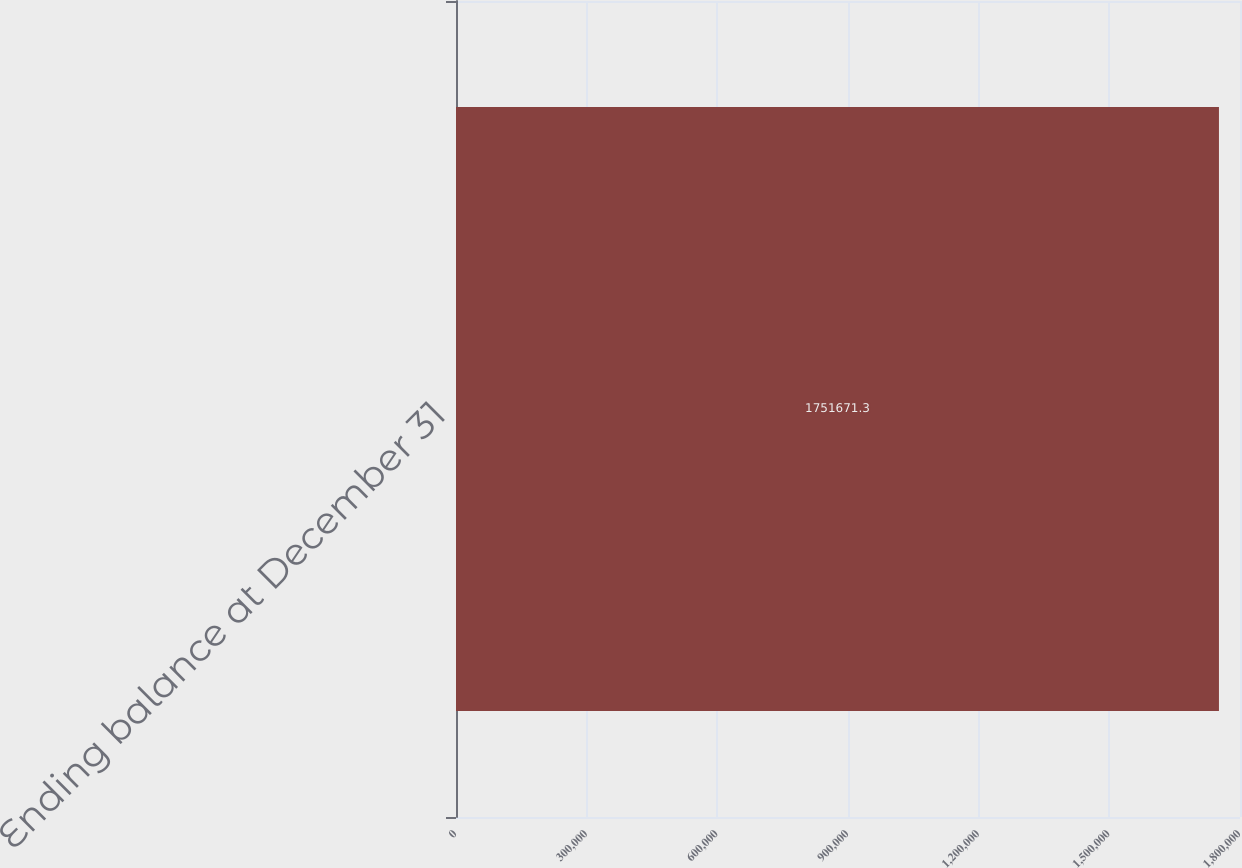<chart> <loc_0><loc_0><loc_500><loc_500><bar_chart><fcel>Ending balance at December 31<nl><fcel>1.75167e+06<nl></chart> 